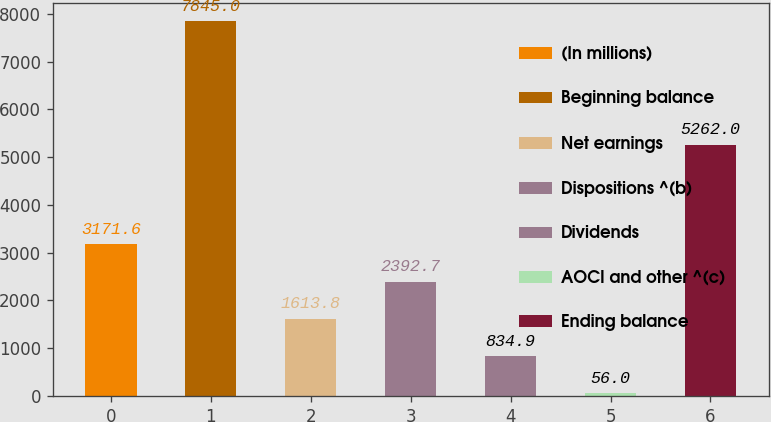<chart> <loc_0><loc_0><loc_500><loc_500><bar_chart><fcel>(In millions)<fcel>Beginning balance<fcel>Net earnings<fcel>Dispositions ^(b)<fcel>Dividends<fcel>AOCI and other ^(c)<fcel>Ending balance<nl><fcel>3171.6<fcel>7845<fcel>1613.8<fcel>2392.7<fcel>834.9<fcel>56<fcel>5262<nl></chart> 